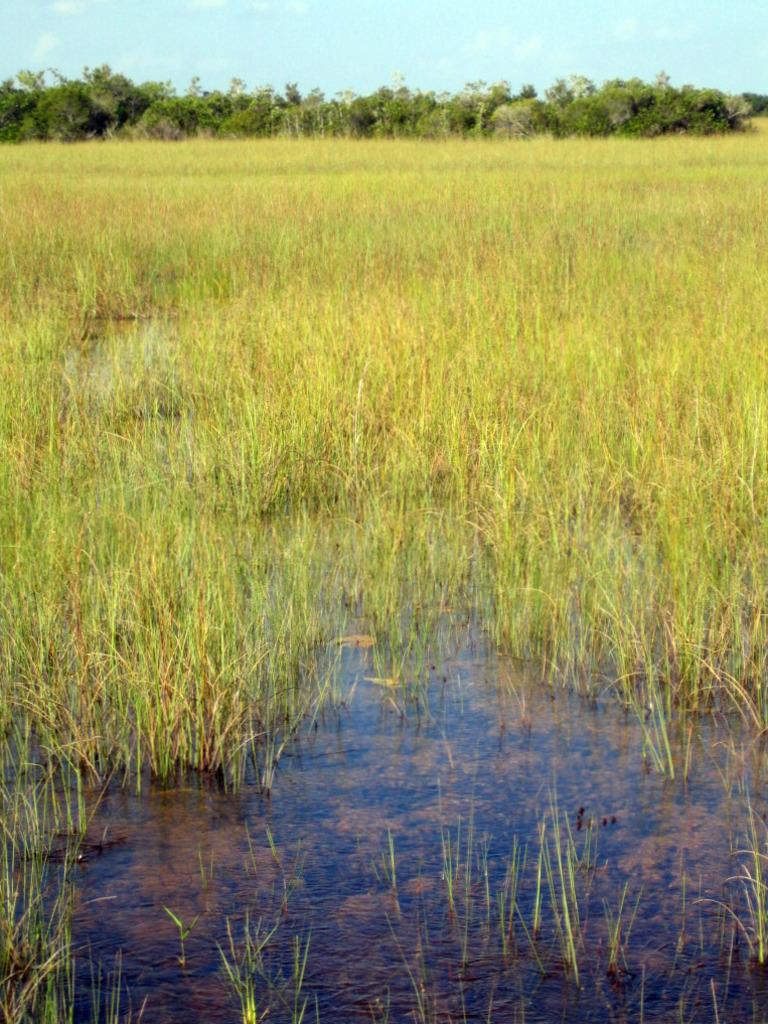What type of ground surface is visible in the image? There is grass on the ground in the image. What else can be seen besides grass in the image? There is water visible in the image, as well as trees. How would you describe the sky in the image? The sky is blue and cloudy in the image. What type of caption is written on the grass in the image? There is no caption written on the grass in the image. What kind of food is being prepared near the water in the image? There is no food preparation or any food visible in the image. 